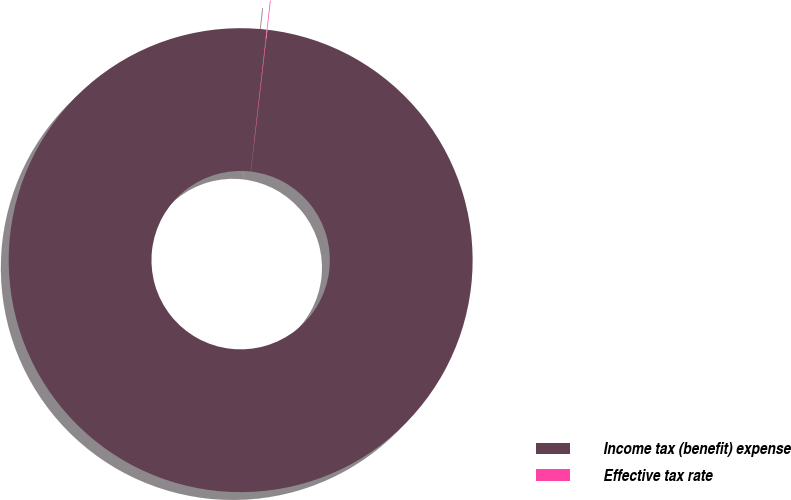<chart> <loc_0><loc_0><loc_500><loc_500><pie_chart><fcel>Income tax (benefit) expense<fcel>Effective tax rate<nl><fcel>99.95%<fcel>0.05%<nl></chart> 